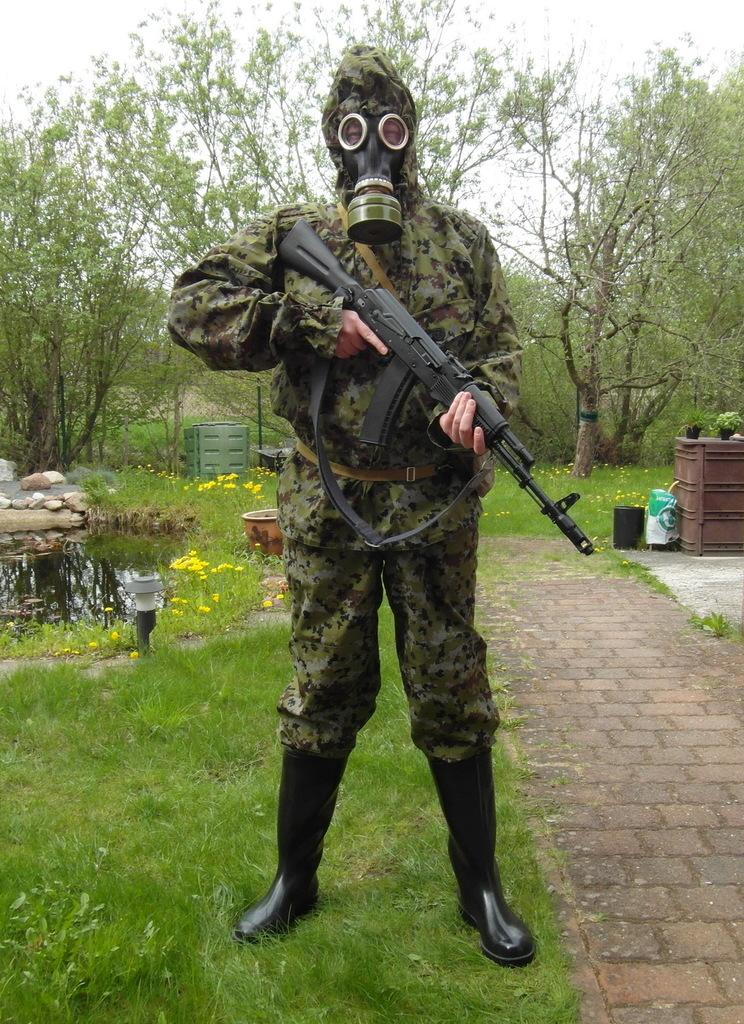Who or what is present in the image? There is a person in the image. What is the person wearing? The person is wearing a face mask. What is the person holding? The person is holding a gun. What can be seen in the background of the image? There are trees in the background of the image. What type of surface is visible in the image? There is grass on the surface in the image. What type of connection can be seen between the person and the trees in the image? There is no visible connection between the person and the trees in the image. 